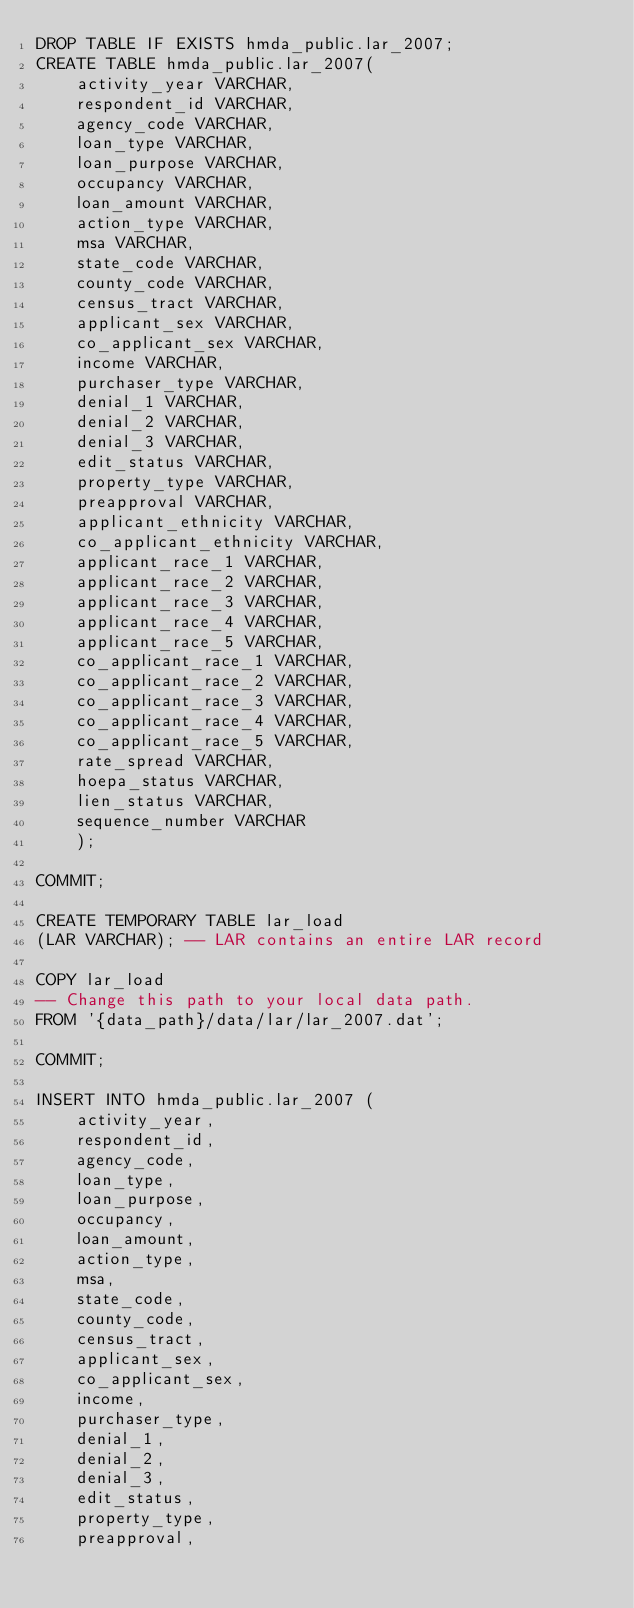<code> <loc_0><loc_0><loc_500><loc_500><_SQL_>DROP TABLE IF EXISTS hmda_public.lar_2007;
CREATE TABLE hmda_public.lar_2007(   
    activity_year VARCHAR,
    respondent_id VARCHAR,
    agency_code VARCHAR,
    loan_type VARCHAR,
    loan_purpose VARCHAR,
    occupancy VARCHAR,
    loan_amount VARCHAR,
    action_type VARCHAR,
    msa VARCHAR,
    state_code VARCHAR,
    county_code VARCHAR,
    census_tract VARCHAR,
    applicant_sex VARCHAR,
    co_applicant_sex VARCHAR,
    income VARCHAR,
    purchaser_type VARCHAR,
    denial_1 VARCHAR,
    denial_2 VARCHAR,
    denial_3 VARCHAR,
    edit_status VARCHAR,
    property_type VARCHAR,
    preapproval VARCHAR,
    applicant_ethnicity VARCHAR,
    co_applicant_ethnicity VARCHAR,
    applicant_race_1 VARCHAR,
    applicant_race_2 VARCHAR,
    applicant_race_3 VARCHAR,
    applicant_race_4 VARCHAR,
    applicant_race_5 VARCHAR,
    co_applicant_race_1 VARCHAR,
    co_applicant_race_2 VARCHAR,
    co_applicant_race_3 VARCHAR,
    co_applicant_race_4 VARCHAR,
    co_applicant_race_5 VARCHAR,
    rate_spread VARCHAR,
    hoepa_status VARCHAR,
    lien_status VARCHAR,
    sequence_number VARCHAR
    );

COMMIT;

CREATE TEMPORARY TABLE lar_load
(LAR VARCHAR); -- LAR contains an entire LAR record

COPY lar_load
-- Change this path to your local data path.
FROM '{data_path}/data/lar/lar_2007.dat';

COMMIT;

INSERT INTO hmda_public.lar_2007 (
    activity_year,
    respondent_id,
    agency_code,
    loan_type,
    loan_purpose,
    occupancy,
    loan_amount,
    action_type,
    msa,
    state_code,
    county_code,
    census_tract,
    applicant_sex,
    co_applicant_sex,
    income,
    purchaser_type,
    denial_1,
    denial_2,
    denial_3,
    edit_status,
    property_type,
    preapproval,</code> 